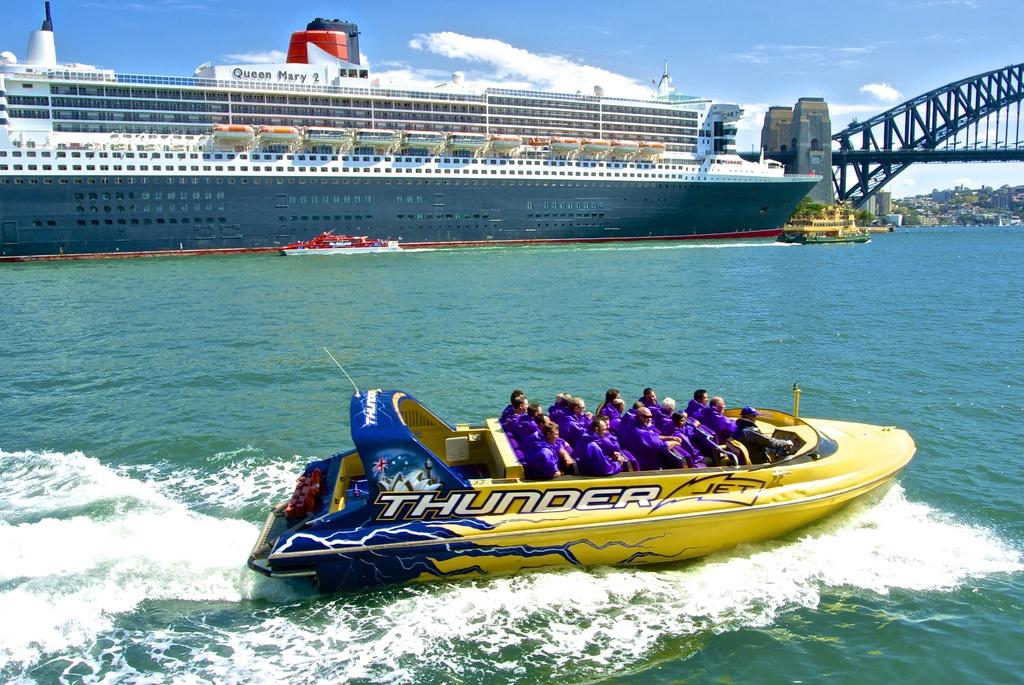What kind of boat is this?
Offer a very short reply. Thunder. What is the ship name?
Give a very brief answer. Thunder jet. 